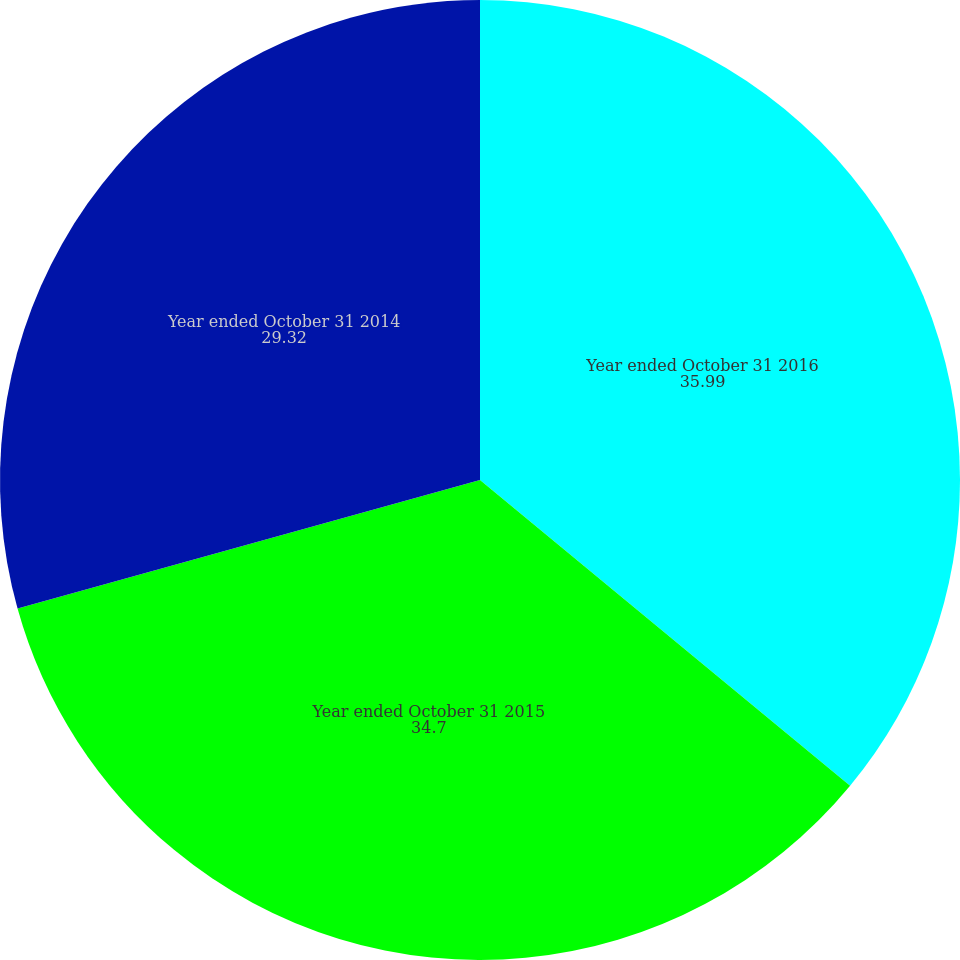Convert chart to OTSL. <chart><loc_0><loc_0><loc_500><loc_500><pie_chart><fcel>Year ended October 31 2016<fcel>Year ended October 31 2015<fcel>Year ended October 31 2014<nl><fcel>35.99%<fcel>34.7%<fcel>29.32%<nl></chart> 